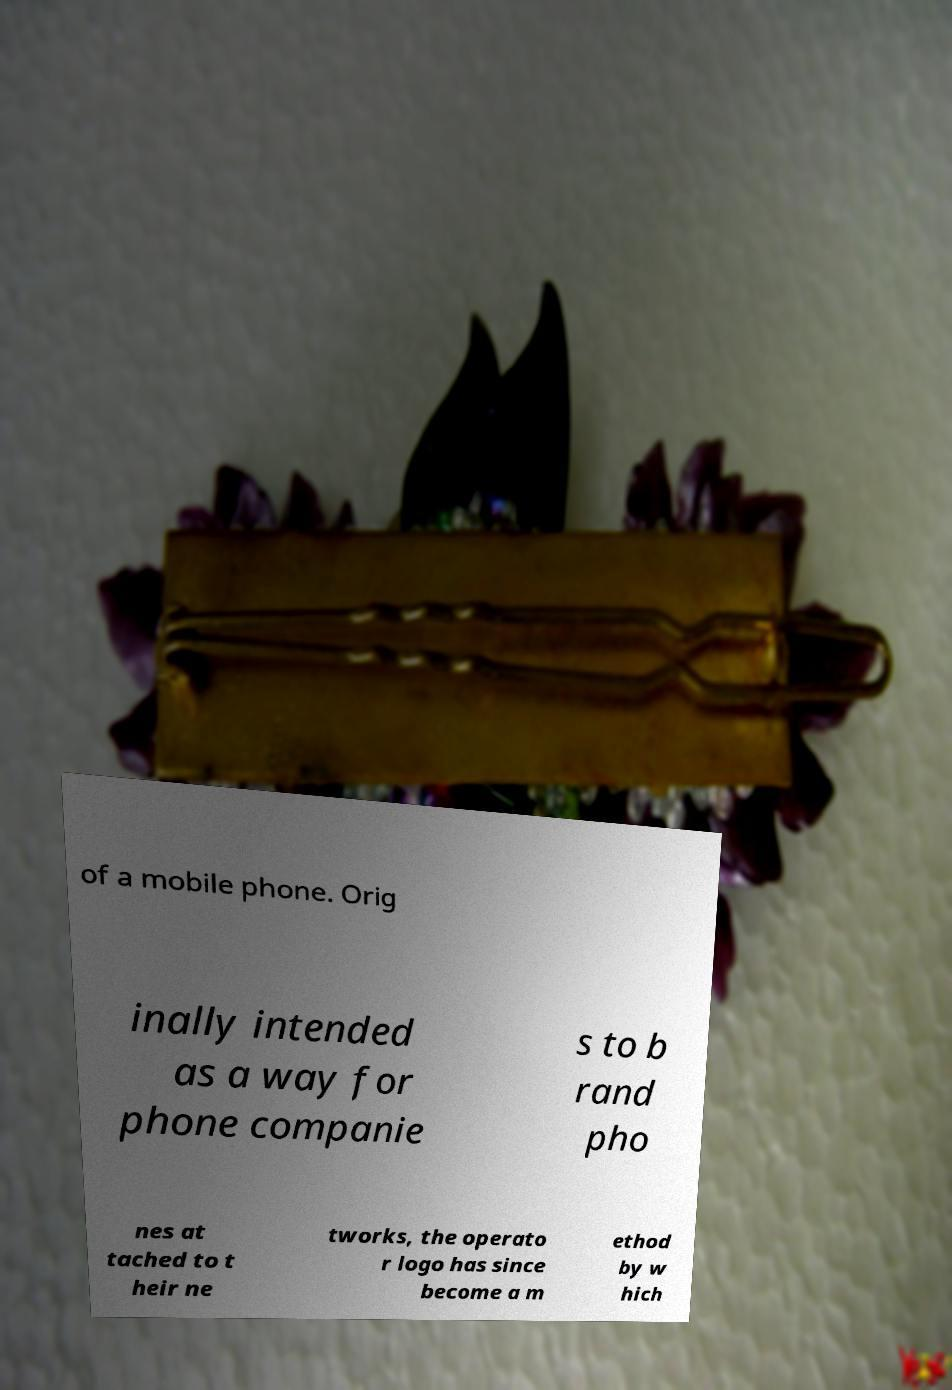Please read and relay the text visible in this image. What does it say? of a mobile phone. Orig inally intended as a way for phone companie s to b rand pho nes at tached to t heir ne tworks, the operato r logo has since become a m ethod by w hich 